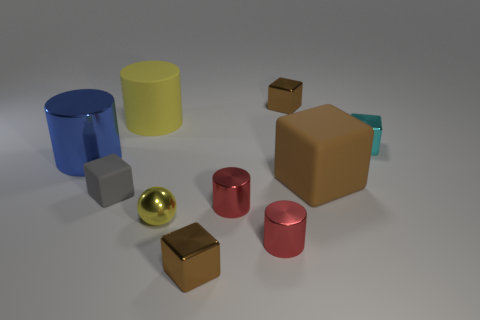Is the shape of the brown object that is behind the cyan shiny block the same as the tiny red thing that is in front of the shiny sphere?
Offer a terse response. No. Are there any cylinders on the left side of the big blue cylinder?
Your response must be concise. No. What is the color of the other big object that is the same shape as the gray rubber object?
Your response must be concise. Brown. Is there any other thing that is the same shape as the yellow rubber object?
Your answer should be compact. Yes. What is the material of the cylinder on the left side of the gray rubber cube?
Your response must be concise. Metal. The brown matte thing that is the same shape as the tiny gray object is what size?
Provide a succinct answer. Large. How many other small blocks are the same material as the cyan block?
Keep it short and to the point. 2. How many matte cubes have the same color as the small rubber object?
Offer a very short reply. 0. How many objects are tiny brown things in front of the blue thing or large objects that are behind the tiny cyan thing?
Your answer should be compact. 2. Is the number of blue shiny cylinders that are right of the large cube less than the number of small green metal spheres?
Offer a terse response. No. 